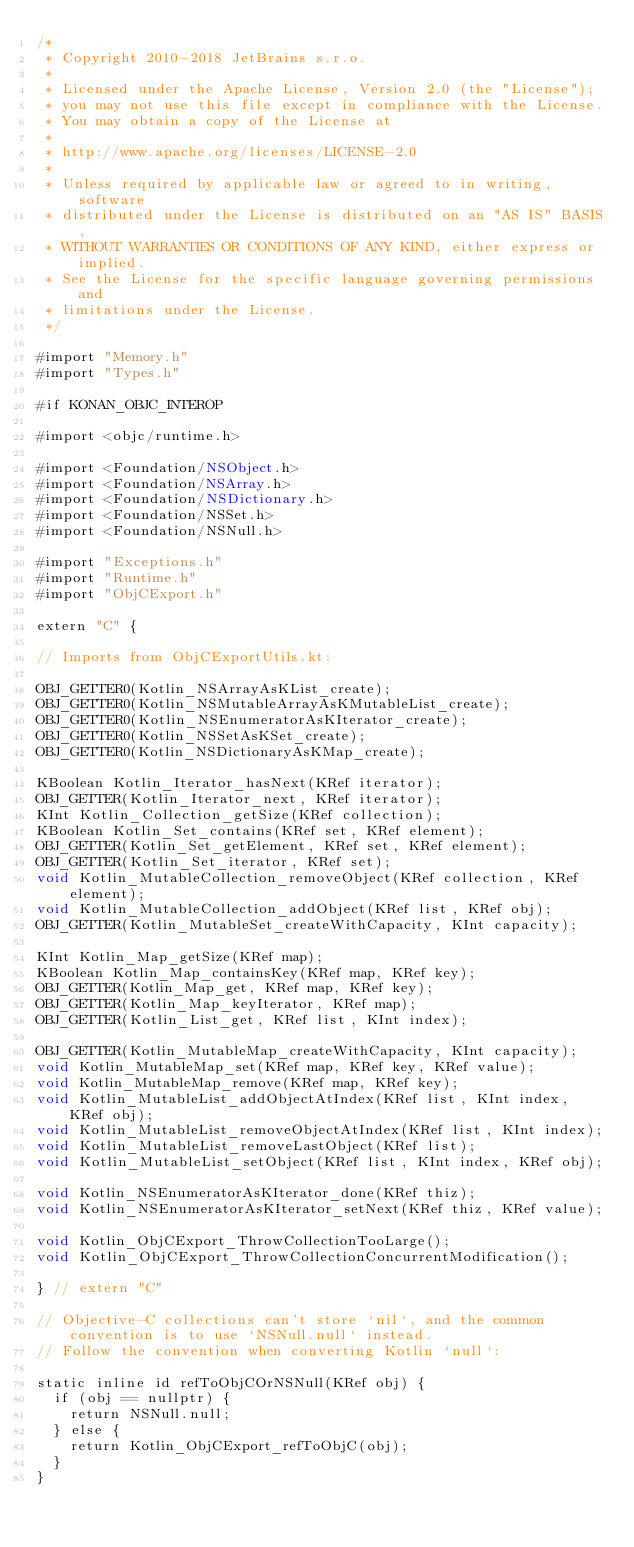<code> <loc_0><loc_0><loc_500><loc_500><_ObjectiveC_>/*
 * Copyright 2010-2018 JetBrains s.r.o.
 *
 * Licensed under the Apache License, Version 2.0 (the "License");
 * you may not use this file except in compliance with the License.
 * You may obtain a copy of the License at
 *
 * http://www.apache.org/licenses/LICENSE-2.0
 *
 * Unless required by applicable law or agreed to in writing, software
 * distributed under the License is distributed on an "AS IS" BASIS,
 * WITHOUT WARRANTIES OR CONDITIONS OF ANY KIND, either express or implied.
 * See the License for the specific language governing permissions and
 * limitations under the License.
 */

#import "Memory.h"
#import "Types.h"

#if KONAN_OBJC_INTEROP

#import <objc/runtime.h>

#import <Foundation/NSObject.h>
#import <Foundation/NSArray.h>
#import <Foundation/NSDictionary.h>
#import <Foundation/NSSet.h>
#import <Foundation/NSNull.h>

#import "Exceptions.h"
#import "Runtime.h"
#import "ObjCExport.h"

extern "C" {

// Imports from ObjCExportUtils.kt:

OBJ_GETTER0(Kotlin_NSArrayAsKList_create);
OBJ_GETTER0(Kotlin_NSMutableArrayAsKMutableList_create);
OBJ_GETTER0(Kotlin_NSEnumeratorAsKIterator_create);
OBJ_GETTER0(Kotlin_NSSetAsKSet_create);
OBJ_GETTER0(Kotlin_NSDictionaryAsKMap_create);

KBoolean Kotlin_Iterator_hasNext(KRef iterator);
OBJ_GETTER(Kotlin_Iterator_next, KRef iterator);
KInt Kotlin_Collection_getSize(KRef collection);
KBoolean Kotlin_Set_contains(KRef set, KRef element);
OBJ_GETTER(Kotlin_Set_getElement, KRef set, KRef element);
OBJ_GETTER(Kotlin_Set_iterator, KRef set);
void Kotlin_MutableCollection_removeObject(KRef collection, KRef element);
void Kotlin_MutableCollection_addObject(KRef list, KRef obj);
OBJ_GETTER(Kotlin_MutableSet_createWithCapacity, KInt capacity);

KInt Kotlin_Map_getSize(KRef map);
KBoolean Kotlin_Map_containsKey(KRef map, KRef key);
OBJ_GETTER(Kotlin_Map_get, KRef map, KRef key);
OBJ_GETTER(Kotlin_Map_keyIterator, KRef map);
OBJ_GETTER(Kotlin_List_get, KRef list, KInt index);

OBJ_GETTER(Kotlin_MutableMap_createWithCapacity, KInt capacity);
void Kotlin_MutableMap_set(KRef map, KRef key, KRef value);
void Kotlin_MutableMap_remove(KRef map, KRef key);
void Kotlin_MutableList_addObjectAtIndex(KRef list, KInt index, KRef obj);
void Kotlin_MutableList_removeObjectAtIndex(KRef list, KInt index);
void Kotlin_MutableList_removeLastObject(KRef list);
void Kotlin_MutableList_setObject(KRef list, KInt index, KRef obj);

void Kotlin_NSEnumeratorAsKIterator_done(KRef thiz);
void Kotlin_NSEnumeratorAsKIterator_setNext(KRef thiz, KRef value);

void Kotlin_ObjCExport_ThrowCollectionTooLarge();
void Kotlin_ObjCExport_ThrowCollectionConcurrentModification();

} // extern "C"

// Objective-C collections can't store `nil`, and the common convention is to use `NSNull.null` instead.
// Follow the convention when converting Kotlin `null`:

static inline id refToObjCOrNSNull(KRef obj) {
  if (obj == nullptr) {
    return NSNull.null;
  } else {
    return Kotlin_ObjCExport_refToObjC(obj);
  }
}
</code> 